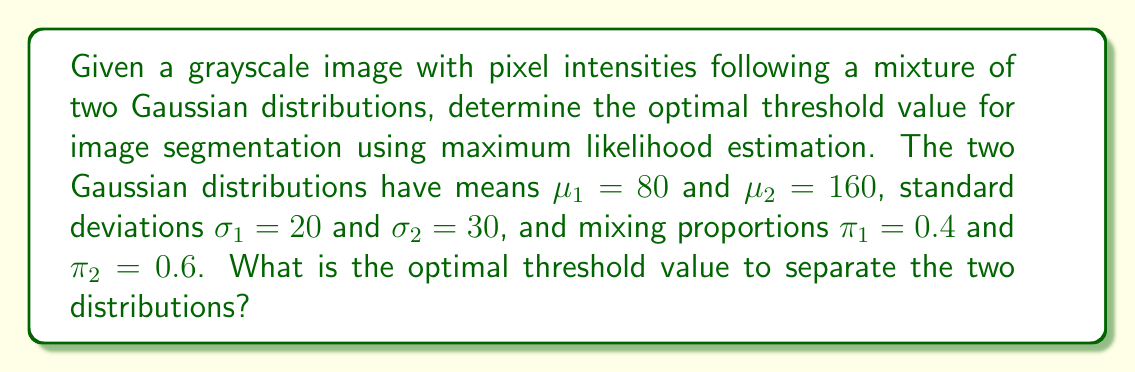Give your solution to this math problem. To determine the optimal threshold value for image segmentation using maximum likelihood estimation, we need to find the point where the probability densities of the two Gaussian distributions are equal. This point represents the intensity value where the likelihood of a pixel belonging to either distribution is the same.

The probability density function (PDF) of a Gaussian distribution is given by:

$$f(x|\mu,\sigma) = \frac{1}{\sigma\sqrt{2\pi}} e^{-\frac{(x-\mu)^2}{2\sigma^2}}$$

For our mixture model, we have:

1. $f_1(x) = \frac{1}{20\sqrt{2\pi}} e^{-\frac{(x-80)^2}{2(20)^2}}$
2. $f_2(x) = \frac{1}{30\sqrt{2\pi}} e^{-\frac{(x-160)^2}{2(30)^2}}$

The mixture model is:

$$f(x) = 0.4 \cdot f_1(x) + 0.6 \cdot f_2(x)$$

To find the optimal threshold, we need to solve:

$$0.4 \cdot f_1(x) = 0.6 \cdot f_2(x)$$

Taking the natural logarithm of both sides:

$$\ln(0.4) + \ln(f_1(x)) = \ln(0.6) + \ln(f_2(x))$$

Substituting the PDFs and simplifying:

$$\ln(0.4) - \ln(20) - \frac{(x-80)^2}{2(20)^2} = \ln(0.6) - \ln(30) - \frac{(x-160)^2}{2(30)^2}$$

Simplifying further:

$$-0.916 - \frac{(x-80)^2}{800} = -0.511 - \frac{(x-160)^2}{1800}$$

Multiplying both sides by -1800:

$$1648.8 + 2.25(x-80)^2 = 919.8 + (x-160)^2$$

Expanding the squares:

$$1648.8 + 2.25(x^2 - 160x + 6400) = 919.8 + x^2 - 320x + 25600$$

Simplifying:

$$1.25x^2 - 360x + 16048.8 = x^2 - 320x + 26519.8$$

Subtracting the right side from both sides:

$$0.25x^2 - 40x - 10471 = 0$$

Multiplying by 4:

$$x^2 - 160x - 41884 = 0$$

Using the quadratic formula:

$$x = \frac{160 \pm \sqrt{160^2 + 4(41884)}}{2} = \frac{160 \pm \sqrt{193136}}{2}$$

$$x = \frac{160 \pm 439.47}{2}$$

The solution we're interested in is the one between the means:

$$x = \frac{160 + 439.47}{2} = 299.735$$

Therefore, the optimal threshold value is approximately 119.87.
Answer: The optimal threshold value for image segmentation is approximately 119.87. 